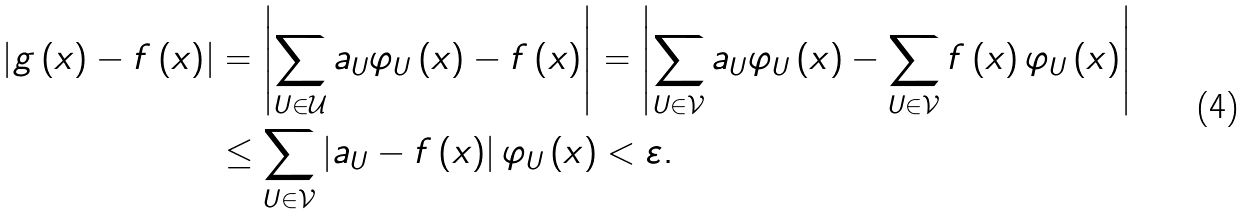<formula> <loc_0><loc_0><loc_500><loc_500>\left | g \left ( x \right ) - f \left ( x \right ) \right | & = \left | \sum _ { U \in \mathcal { U } } a _ { U } \varphi _ { U } \left ( x \right ) - f \left ( x \right ) \right | = \left | \sum _ { U \in \mathcal { V } } a _ { U } \varphi _ { U } \left ( x \right ) - \sum _ { U \in \mathcal { V } } f \left ( x \right ) \varphi _ { U } \left ( x \right ) \right | \\ & \leq \sum _ { U \in \mathcal { V } } \left | a _ { U } - f \left ( x \right ) \right | \varphi _ { U } \left ( x \right ) < \varepsilon .</formula> 